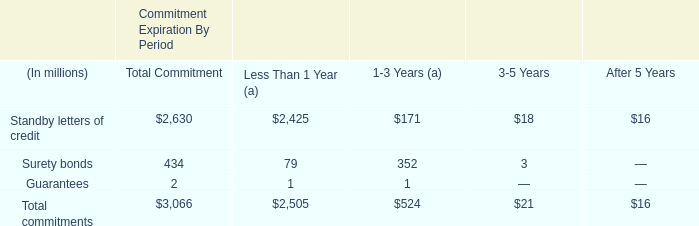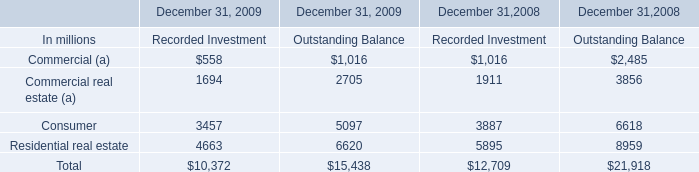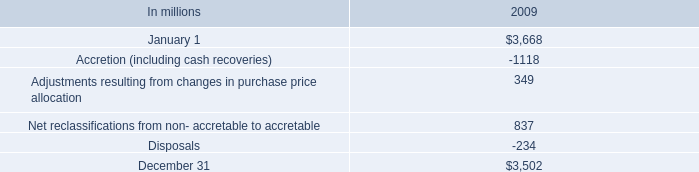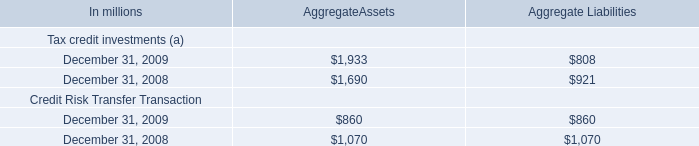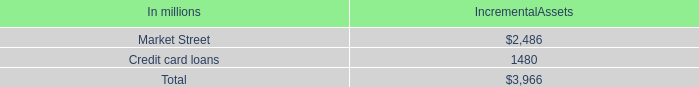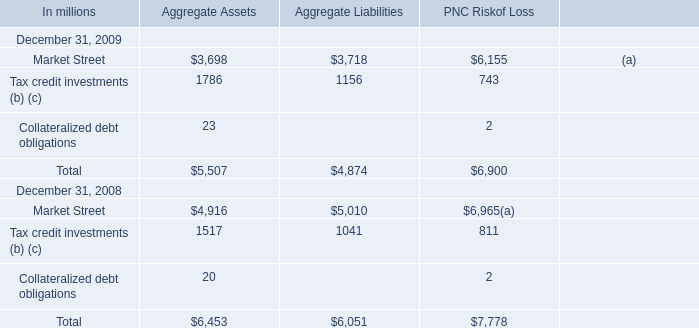How many elements show negative value in 2009 for AggregateAssets? 
Answer: 0. 